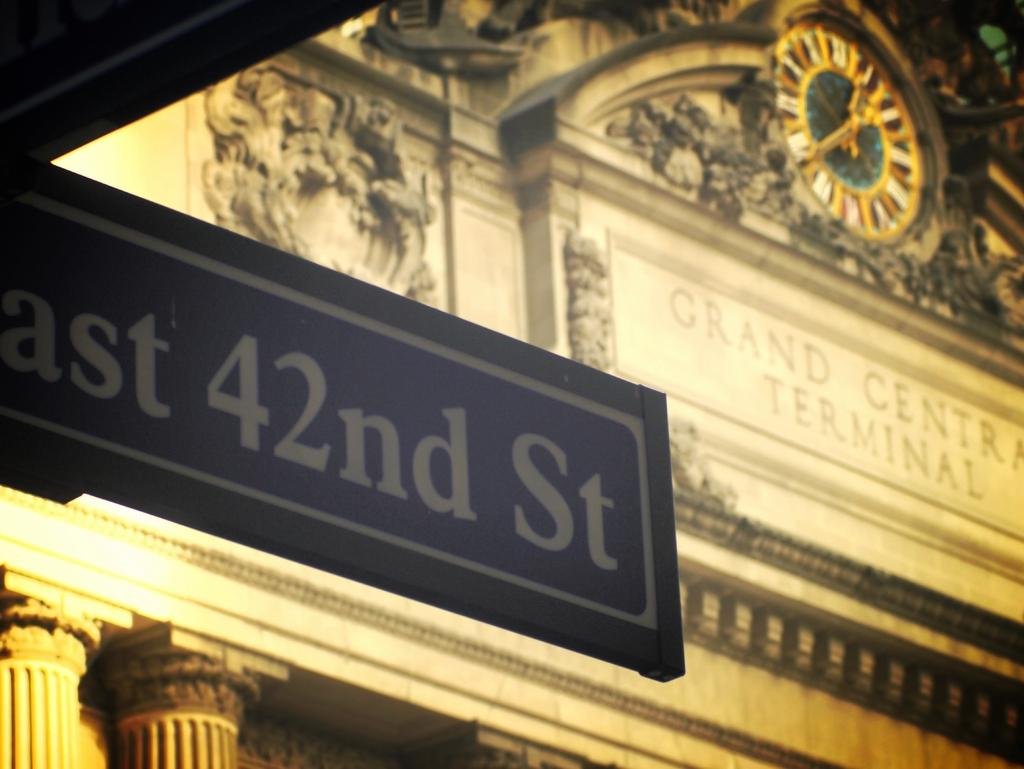<image>
Summarize the visual content of the image. A sign with 42nd St is in front of a terminal. 